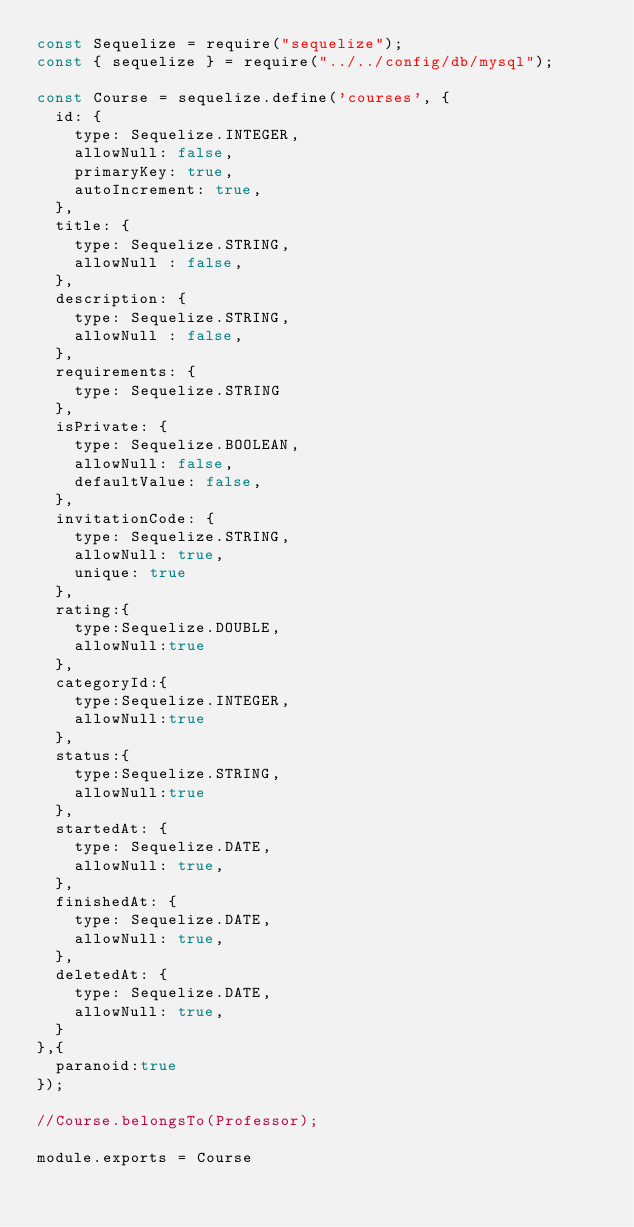Convert code to text. <code><loc_0><loc_0><loc_500><loc_500><_JavaScript_>const Sequelize = require("sequelize");
const { sequelize } = require("../../config/db/mysql");

const Course = sequelize.define('courses', {
  id: {
    type: Sequelize.INTEGER,
    allowNull: false,
    primaryKey: true,
    autoIncrement: true,
  },
  title: {
    type: Sequelize.STRING,
    allowNull : false,
  },
  description: {
    type: Sequelize.STRING,
    allowNull : false,
  },
  requirements: {
    type: Sequelize.STRING
  },
  isPrivate: {  
    type: Sequelize.BOOLEAN,
    allowNull: false,
    defaultValue: false,
  },
  invitationCode: {
    type: Sequelize.STRING,
    allowNull: true,
    unique: true
  },
  rating:{
    type:Sequelize.DOUBLE,
    allowNull:true
  },
  categoryId:{
    type:Sequelize.INTEGER,
    allowNull:true
  },
  status:{
    type:Sequelize.STRING,
    allowNull:true
  },
  startedAt: {
    type: Sequelize.DATE,
    allowNull: true,
  },
  finishedAt: {
    type: Sequelize.DATE,
    allowNull: true,
  },
  deletedAt: {
    type: Sequelize.DATE,
    allowNull: true,
  }
},{
  paranoid:true
});

//Course.belongsTo(Professor);

module.exports = Course
</code> 